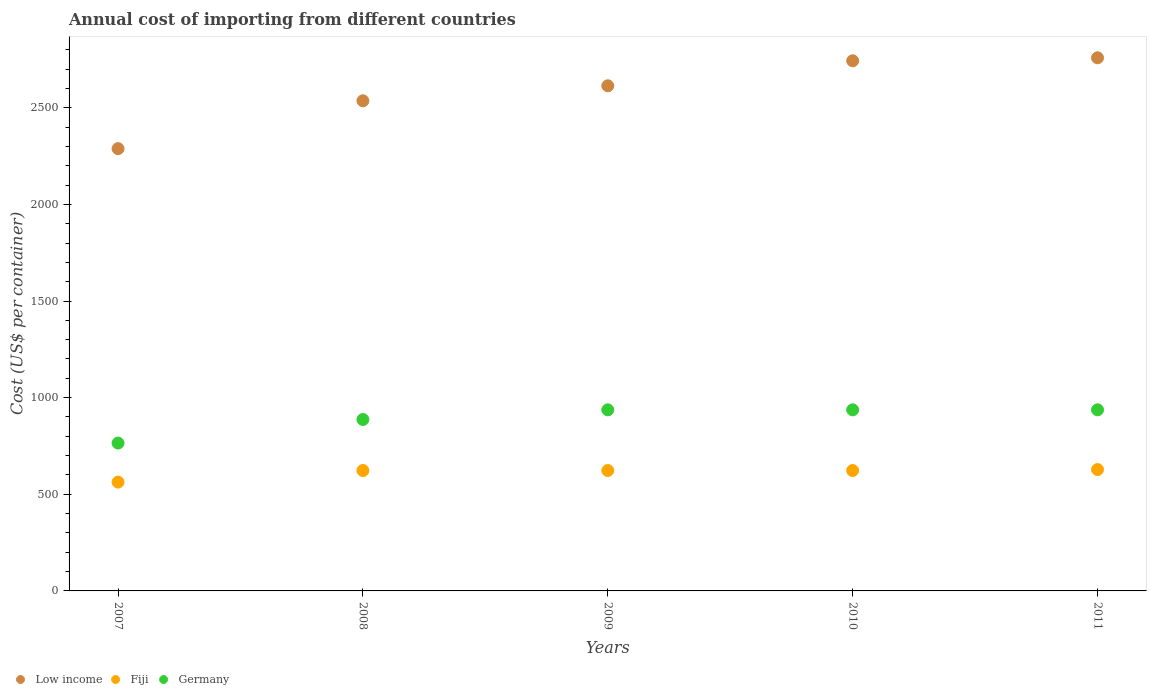How many different coloured dotlines are there?
Make the answer very short. 3. What is the total annual cost of importing in Germany in 2007?
Your answer should be compact. 765. Across all years, what is the maximum total annual cost of importing in Germany?
Your answer should be compact. 937. Across all years, what is the minimum total annual cost of importing in Germany?
Provide a succinct answer. 765. In which year was the total annual cost of importing in Germany minimum?
Ensure brevity in your answer.  2007. What is the total total annual cost of importing in Germany in the graph?
Your answer should be very brief. 4463. What is the difference between the total annual cost of importing in Germany in 2007 and that in 2009?
Offer a very short reply. -172. What is the difference between the total annual cost of importing in Germany in 2008 and the total annual cost of importing in Low income in 2010?
Keep it short and to the point. -1855.82. What is the average total annual cost of importing in Low income per year?
Make the answer very short. 2587.78. In the year 2007, what is the difference between the total annual cost of importing in Fiji and total annual cost of importing in Germany?
Keep it short and to the point. -202. In how many years, is the total annual cost of importing in Low income greater than 200 US$?
Keep it short and to the point. 5. What is the ratio of the total annual cost of importing in Low income in 2007 to that in 2008?
Offer a very short reply. 0.9. Is the difference between the total annual cost of importing in Fiji in 2010 and 2011 greater than the difference between the total annual cost of importing in Germany in 2010 and 2011?
Ensure brevity in your answer.  No. What is the difference between the highest and the lowest total annual cost of importing in Low income?
Your answer should be very brief. 470.11. Does the total annual cost of importing in Low income monotonically increase over the years?
Give a very brief answer. Yes. Is the total annual cost of importing in Fiji strictly greater than the total annual cost of importing in Low income over the years?
Provide a short and direct response. No. Is the total annual cost of importing in Germany strictly less than the total annual cost of importing in Low income over the years?
Provide a short and direct response. Yes. How many dotlines are there?
Provide a succinct answer. 3. How many years are there in the graph?
Keep it short and to the point. 5. Does the graph contain grids?
Provide a short and direct response. No. Where does the legend appear in the graph?
Your answer should be very brief. Bottom left. How many legend labels are there?
Keep it short and to the point. 3. How are the legend labels stacked?
Ensure brevity in your answer.  Horizontal. What is the title of the graph?
Your answer should be very brief. Annual cost of importing from different countries. What is the label or title of the Y-axis?
Provide a short and direct response. Cost (US$ per container). What is the Cost (US$ per container) in Low income in 2007?
Your answer should be very brief. 2288.29. What is the Cost (US$ per container) in Fiji in 2007?
Your answer should be very brief. 563. What is the Cost (US$ per container) in Germany in 2007?
Your answer should be compact. 765. What is the Cost (US$ per container) of Low income in 2008?
Offer a terse response. 2535.93. What is the Cost (US$ per container) in Fiji in 2008?
Provide a short and direct response. 623. What is the Cost (US$ per container) in Germany in 2008?
Offer a very short reply. 887. What is the Cost (US$ per container) in Low income in 2009?
Your answer should be compact. 2613.46. What is the Cost (US$ per container) of Fiji in 2009?
Provide a succinct answer. 623. What is the Cost (US$ per container) in Germany in 2009?
Your response must be concise. 937. What is the Cost (US$ per container) of Low income in 2010?
Your answer should be compact. 2742.82. What is the Cost (US$ per container) in Fiji in 2010?
Provide a short and direct response. 623. What is the Cost (US$ per container) of Germany in 2010?
Make the answer very short. 937. What is the Cost (US$ per container) of Low income in 2011?
Provide a short and direct response. 2758.39. What is the Cost (US$ per container) of Fiji in 2011?
Ensure brevity in your answer.  628. What is the Cost (US$ per container) of Germany in 2011?
Offer a terse response. 937. Across all years, what is the maximum Cost (US$ per container) in Low income?
Your answer should be very brief. 2758.39. Across all years, what is the maximum Cost (US$ per container) of Fiji?
Provide a short and direct response. 628. Across all years, what is the maximum Cost (US$ per container) of Germany?
Your response must be concise. 937. Across all years, what is the minimum Cost (US$ per container) of Low income?
Provide a succinct answer. 2288.29. Across all years, what is the minimum Cost (US$ per container) in Fiji?
Make the answer very short. 563. Across all years, what is the minimum Cost (US$ per container) of Germany?
Your answer should be compact. 765. What is the total Cost (US$ per container) in Low income in the graph?
Your response must be concise. 1.29e+04. What is the total Cost (US$ per container) in Fiji in the graph?
Offer a terse response. 3060. What is the total Cost (US$ per container) of Germany in the graph?
Your answer should be very brief. 4463. What is the difference between the Cost (US$ per container) in Low income in 2007 and that in 2008?
Offer a terse response. -247.64. What is the difference between the Cost (US$ per container) in Fiji in 2007 and that in 2008?
Keep it short and to the point. -60. What is the difference between the Cost (US$ per container) of Germany in 2007 and that in 2008?
Offer a terse response. -122. What is the difference between the Cost (US$ per container) of Low income in 2007 and that in 2009?
Provide a short and direct response. -325.18. What is the difference between the Cost (US$ per container) of Fiji in 2007 and that in 2009?
Offer a very short reply. -60. What is the difference between the Cost (US$ per container) in Germany in 2007 and that in 2009?
Ensure brevity in your answer.  -172. What is the difference between the Cost (US$ per container) in Low income in 2007 and that in 2010?
Your answer should be very brief. -454.54. What is the difference between the Cost (US$ per container) of Fiji in 2007 and that in 2010?
Provide a short and direct response. -60. What is the difference between the Cost (US$ per container) in Germany in 2007 and that in 2010?
Provide a succinct answer. -172. What is the difference between the Cost (US$ per container) in Low income in 2007 and that in 2011?
Your response must be concise. -470.11. What is the difference between the Cost (US$ per container) of Fiji in 2007 and that in 2011?
Ensure brevity in your answer.  -65. What is the difference between the Cost (US$ per container) in Germany in 2007 and that in 2011?
Your response must be concise. -172. What is the difference between the Cost (US$ per container) in Low income in 2008 and that in 2009?
Give a very brief answer. -77.54. What is the difference between the Cost (US$ per container) of Germany in 2008 and that in 2009?
Your answer should be very brief. -50. What is the difference between the Cost (US$ per container) of Low income in 2008 and that in 2010?
Keep it short and to the point. -206.89. What is the difference between the Cost (US$ per container) in Fiji in 2008 and that in 2010?
Your response must be concise. 0. What is the difference between the Cost (US$ per container) of Germany in 2008 and that in 2010?
Offer a very short reply. -50. What is the difference between the Cost (US$ per container) of Low income in 2008 and that in 2011?
Your response must be concise. -222.46. What is the difference between the Cost (US$ per container) in Fiji in 2008 and that in 2011?
Make the answer very short. -5. What is the difference between the Cost (US$ per container) of Low income in 2009 and that in 2010?
Offer a terse response. -129.36. What is the difference between the Cost (US$ per container) of Germany in 2009 and that in 2010?
Your response must be concise. 0. What is the difference between the Cost (US$ per container) in Low income in 2009 and that in 2011?
Keep it short and to the point. -144.93. What is the difference between the Cost (US$ per container) of Germany in 2009 and that in 2011?
Make the answer very short. 0. What is the difference between the Cost (US$ per container) of Low income in 2010 and that in 2011?
Offer a very short reply. -15.57. What is the difference between the Cost (US$ per container) of Low income in 2007 and the Cost (US$ per container) of Fiji in 2008?
Provide a succinct answer. 1665.29. What is the difference between the Cost (US$ per container) in Low income in 2007 and the Cost (US$ per container) in Germany in 2008?
Keep it short and to the point. 1401.29. What is the difference between the Cost (US$ per container) in Fiji in 2007 and the Cost (US$ per container) in Germany in 2008?
Give a very brief answer. -324. What is the difference between the Cost (US$ per container) of Low income in 2007 and the Cost (US$ per container) of Fiji in 2009?
Provide a succinct answer. 1665.29. What is the difference between the Cost (US$ per container) of Low income in 2007 and the Cost (US$ per container) of Germany in 2009?
Keep it short and to the point. 1351.29. What is the difference between the Cost (US$ per container) in Fiji in 2007 and the Cost (US$ per container) in Germany in 2009?
Ensure brevity in your answer.  -374. What is the difference between the Cost (US$ per container) of Low income in 2007 and the Cost (US$ per container) of Fiji in 2010?
Keep it short and to the point. 1665.29. What is the difference between the Cost (US$ per container) in Low income in 2007 and the Cost (US$ per container) in Germany in 2010?
Ensure brevity in your answer.  1351.29. What is the difference between the Cost (US$ per container) of Fiji in 2007 and the Cost (US$ per container) of Germany in 2010?
Ensure brevity in your answer.  -374. What is the difference between the Cost (US$ per container) of Low income in 2007 and the Cost (US$ per container) of Fiji in 2011?
Your response must be concise. 1660.29. What is the difference between the Cost (US$ per container) in Low income in 2007 and the Cost (US$ per container) in Germany in 2011?
Ensure brevity in your answer.  1351.29. What is the difference between the Cost (US$ per container) of Fiji in 2007 and the Cost (US$ per container) of Germany in 2011?
Ensure brevity in your answer.  -374. What is the difference between the Cost (US$ per container) in Low income in 2008 and the Cost (US$ per container) in Fiji in 2009?
Your response must be concise. 1912.93. What is the difference between the Cost (US$ per container) in Low income in 2008 and the Cost (US$ per container) in Germany in 2009?
Ensure brevity in your answer.  1598.93. What is the difference between the Cost (US$ per container) in Fiji in 2008 and the Cost (US$ per container) in Germany in 2009?
Provide a succinct answer. -314. What is the difference between the Cost (US$ per container) of Low income in 2008 and the Cost (US$ per container) of Fiji in 2010?
Your answer should be compact. 1912.93. What is the difference between the Cost (US$ per container) in Low income in 2008 and the Cost (US$ per container) in Germany in 2010?
Your answer should be very brief. 1598.93. What is the difference between the Cost (US$ per container) of Fiji in 2008 and the Cost (US$ per container) of Germany in 2010?
Offer a terse response. -314. What is the difference between the Cost (US$ per container) of Low income in 2008 and the Cost (US$ per container) of Fiji in 2011?
Provide a short and direct response. 1907.93. What is the difference between the Cost (US$ per container) of Low income in 2008 and the Cost (US$ per container) of Germany in 2011?
Your answer should be very brief. 1598.93. What is the difference between the Cost (US$ per container) in Fiji in 2008 and the Cost (US$ per container) in Germany in 2011?
Keep it short and to the point. -314. What is the difference between the Cost (US$ per container) of Low income in 2009 and the Cost (US$ per container) of Fiji in 2010?
Offer a very short reply. 1990.46. What is the difference between the Cost (US$ per container) in Low income in 2009 and the Cost (US$ per container) in Germany in 2010?
Provide a short and direct response. 1676.46. What is the difference between the Cost (US$ per container) of Fiji in 2009 and the Cost (US$ per container) of Germany in 2010?
Offer a terse response. -314. What is the difference between the Cost (US$ per container) in Low income in 2009 and the Cost (US$ per container) in Fiji in 2011?
Provide a short and direct response. 1985.46. What is the difference between the Cost (US$ per container) in Low income in 2009 and the Cost (US$ per container) in Germany in 2011?
Your response must be concise. 1676.46. What is the difference between the Cost (US$ per container) in Fiji in 2009 and the Cost (US$ per container) in Germany in 2011?
Give a very brief answer. -314. What is the difference between the Cost (US$ per container) in Low income in 2010 and the Cost (US$ per container) in Fiji in 2011?
Keep it short and to the point. 2114.82. What is the difference between the Cost (US$ per container) in Low income in 2010 and the Cost (US$ per container) in Germany in 2011?
Offer a very short reply. 1805.82. What is the difference between the Cost (US$ per container) of Fiji in 2010 and the Cost (US$ per container) of Germany in 2011?
Ensure brevity in your answer.  -314. What is the average Cost (US$ per container) in Low income per year?
Keep it short and to the point. 2587.78. What is the average Cost (US$ per container) in Fiji per year?
Keep it short and to the point. 612. What is the average Cost (US$ per container) of Germany per year?
Provide a succinct answer. 892.6. In the year 2007, what is the difference between the Cost (US$ per container) in Low income and Cost (US$ per container) in Fiji?
Keep it short and to the point. 1725.29. In the year 2007, what is the difference between the Cost (US$ per container) of Low income and Cost (US$ per container) of Germany?
Give a very brief answer. 1523.29. In the year 2007, what is the difference between the Cost (US$ per container) in Fiji and Cost (US$ per container) in Germany?
Offer a terse response. -202. In the year 2008, what is the difference between the Cost (US$ per container) in Low income and Cost (US$ per container) in Fiji?
Offer a terse response. 1912.93. In the year 2008, what is the difference between the Cost (US$ per container) in Low income and Cost (US$ per container) in Germany?
Offer a very short reply. 1648.93. In the year 2008, what is the difference between the Cost (US$ per container) of Fiji and Cost (US$ per container) of Germany?
Offer a terse response. -264. In the year 2009, what is the difference between the Cost (US$ per container) of Low income and Cost (US$ per container) of Fiji?
Provide a short and direct response. 1990.46. In the year 2009, what is the difference between the Cost (US$ per container) in Low income and Cost (US$ per container) in Germany?
Your answer should be compact. 1676.46. In the year 2009, what is the difference between the Cost (US$ per container) in Fiji and Cost (US$ per container) in Germany?
Your answer should be very brief. -314. In the year 2010, what is the difference between the Cost (US$ per container) in Low income and Cost (US$ per container) in Fiji?
Offer a very short reply. 2119.82. In the year 2010, what is the difference between the Cost (US$ per container) of Low income and Cost (US$ per container) of Germany?
Your response must be concise. 1805.82. In the year 2010, what is the difference between the Cost (US$ per container) of Fiji and Cost (US$ per container) of Germany?
Keep it short and to the point. -314. In the year 2011, what is the difference between the Cost (US$ per container) in Low income and Cost (US$ per container) in Fiji?
Ensure brevity in your answer.  2130.39. In the year 2011, what is the difference between the Cost (US$ per container) of Low income and Cost (US$ per container) of Germany?
Give a very brief answer. 1821.39. In the year 2011, what is the difference between the Cost (US$ per container) of Fiji and Cost (US$ per container) of Germany?
Your answer should be compact. -309. What is the ratio of the Cost (US$ per container) of Low income in 2007 to that in 2008?
Your answer should be compact. 0.9. What is the ratio of the Cost (US$ per container) in Fiji in 2007 to that in 2008?
Your answer should be compact. 0.9. What is the ratio of the Cost (US$ per container) in Germany in 2007 to that in 2008?
Make the answer very short. 0.86. What is the ratio of the Cost (US$ per container) of Low income in 2007 to that in 2009?
Your answer should be very brief. 0.88. What is the ratio of the Cost (US$ per container) of Fiji in 2007 to that in 2009?
Your response must be concise. 0.9. What is the ratio of the Cost (US$ per container) of Germany in 2007 to that in 2009?
Your response must be concise. 0.82. What is the ratio of the Cost (US$ per container) of Low income in 2007 to that in 2010?
Your answer should be very brief. 0.83. What is the ratio of the Cost (US$ per container) in Fiji in 2007 to that in 2010?
Make the answer very short. 0.9. What is the ratio of the Cost (US$ per container) in Germany in 2007 to that in 2010?
Give a very brief answer. 0.82. What is the ratio of the Cost (US$ per container) of Low income in 2007 to that in 2011?
Offer a very short reply. 0.83. What is the ratio of the Cost (US$ per container) in Fiji in 2007 to that in 2011?
Your response must be concise. 0.9. What is the ratio of the Cost (US$ per container) in Germany in 2007 to that in 2011?
Offer a terse response. 0.82. What is the ratio of the Cost (US$ per container) in Low income in 2008 to that in 2009?
Provide a short and direct response. 0.97. What is the ratio of the Cost (US$ per container) in Germany in 2008 to that in 2009?
Ensure brevity in your answer.  0.95. What is the ratio of the Cost (US$ per container) of Low income in 2008 to that in 2010?
Make the answer very short. 0.92. What is the ratio of the Cost (US$ per container) in Germany in 2008 to that in 2010?
Ensure brevity in your answer.  0.95. What is the ratio of the Cost (US$ per container) in Low income in 2008 to that in 2011?
Keep it short and to the point. 0.92. What is the ratio of the Cost (US$ per container) of Fiji in 2008 to that in 2011?
Make the answer very short. 0.99. What is the ratio of the Cost (US$ per container) of Germany in 2008 to that in 2011?
Provide a succinct answer. 0.95. What is the ratio of the Cost (US$ per container) of Low income in 2009 to that in 2010?
Your answer should be very brief. 0.95. What is the ratio of the Cost (US$ per container) of Germany in 2009 to that in 2010?
Your response must be concise. 1. What is the ratio of the Cost (US$ per container) of Low income in 2009 to that in 2011?
Make the answer very short. 0.95. What is the ratio of the Cost (US$ per container) in Germany in 2009 to that in 2011?
Ensure brevity in your answer.  1. What is the ratio of the Cost (US$ per container) of Low income in 2010 to that in 2011?
Give a very brief answer. 0.99. What is the ratio of the Cost (US$ per container) in Fiji in 2010 to that in 2011?
Your answer should be compact. 0.99. What is the ratio of the Cost (US$ per container) in Germany in 2010 to that in 2011?
Give a very brief answer. 1. What is the difference between the highest and the second highest Cost (US$ per container) in Low income?
Offer a very short reply. 15.57. What is the difference between the highest and the second highest Cost (US$ per container) in Fiji?
Keep it short and to the point. 5. What is the difference between the highest and the second highest Cost (US$ per container) in Germany?
Your answer should be compact. 0. What is the difference between the highest and the lowest Cost (US$ per container) in Low income?
Offer a very short reply. 470.11. What is the difference between the highest and the lowest Cost (US$ per container) in Fiji?
Make the answer very short. 65. What is the difference between the highest and the lowest Cost (US$ per container) in Germany?
Your answer should be compact. 172. 